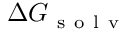<formula> <loc_0><loc_0><loc_500><loc_500>\Delta G _ { s o l v }</formula> 